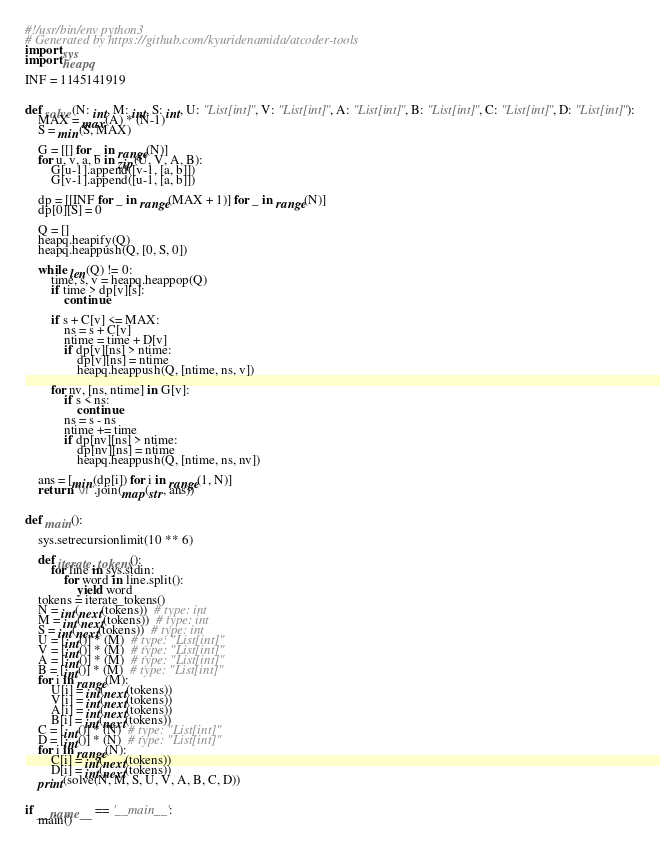<code> <loc_0><loc_0><loc_500><loc_500><_Python_>#!/usr/bin/env python3
# Generated by https://github.com/kyuridenamida/atcoder-tools
import sys
import heapq

INF = 1145141919


def solve(N: int, M: int, S: int, U: "List[int]", V: "List[int]", A: "List[int]", B: "List[int]", C: "List[int]", D: "List[int]"):
    MAX = max(A) * (N-1)
    S = min(S, MAX)

    G = [[] for _ in range(N)]
    for u, v, a, b in zip(U, V, A, B):
        G[u-1].append([v-1, [a, b]])
        G[v-1].append([u-1, [a, b]])

    dp = [[INF for _ in range(MAX + 1)] for _ in range(N)]
    dp[0][S] = 0

    Q = []
    heapq.heapify(Q)
    heapq.heappush(Q, [0, S, 0])

    while len(Q) != 0:
        time, s, v = heapq.heappop(Q)
        if time > dp[v][s]:
            continue

        if s + C[v] <= MAX:
            ns = s + C[v]
            ntime = time + D[v]
            if dp[v][ns] > ntime:
                dp[v][ns] = ntime
                heapq.heappush(Q, [ntime, ns, v])

        for nv, [ns, ntime] in G[v]:
            if s < ns:
                continue
            ns = s - ns
            ntime += time
            if dp[nv][ns] > ntime:
                dp[nv][ns] = ntime
                heapq.heappush(Q, [ntime, ns, nv])

    ans = [min(dp[i]) for i in range(1, N)]
    return "\n".join(map(str, ans))


def main():

    sys.setrecursionlimit(10 ** 6)

    def iterate_tokens():
        for line in sys.stdin:
            for word in line.split():
                yield word
    tokens = iterate_tokens()
    N = int(next(tokens))  # type: int
    M = int(next(tokens))  # type: int
    S = int(next(tokens))  # type: int
    U = [int()] * (M)  # type: "List[int]"
    V = [int()] * (M)  # type: "List[int]"
    A = [int()] * (M)  # type: "List[int]"
    B = [int()] * (M)  # type: "List[int]"
    for i in range(M):
        U[i] = int(next(tokens))
        V[i] = int(next(tokens))
        A[i] = int(next(tokens))
        B[i] = int(next(tokens))
    C = [int()] * (N)  # type: "List[int]"
    D = [int()] * (N)  # type: "List[int]"
    for i in range(N):
        C[i] = int(next(tokens))
        D[i] = int(next(tokens))
    print(solve(N, M, S, U, V, A, B, C, D))


if __name__ == '__main__':
    main()
</code> 